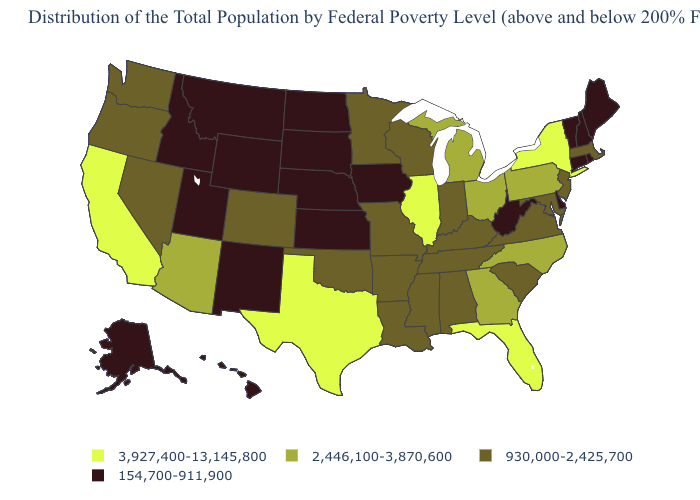What is the value of Kansas?
Write a very short answer. 154,700-911,900. Name the states that have a value in the range 930,000-2,425,700?
Concise answer only. Alabama, Arkansas, Colorado, Indiana, Kentucky, Louisiana, Maryland, Massachusetts, Minnesota, Mississippi, Missouri, Nevada, New Jersey, Oklahoma, Oregon, South Carolina, Tennessee, Virginia, Washington, Wisconsin. What is the highest value in the USA?
Quick response, please. 3,927,400-13,145,800. Name the states that have a value in the range 154,700-911,900?
Answer briefly. Alaska, Connecticut, Delaware, Hawaii, Idaho, Iowa, Kansas, Maine, Montana, Nebraska, New Hampshire, New Mexico, North Dakota, Rhode Island, South Dakota, Utah, Vermont, West Virginia, Wyoming. How many symbols are there in the legend?
Short answer required. 4. What is the value of Idaho?
Be succinct. 154,700-911,900. Among the states that border Nebraska , which have the highest value?
Be succinct. Colorado, Missouri. Name the states that have a value in the range 3,927,400-13,145,800?
Write a very short answer. California, Florida, Illinois, New York, Texas. How many symbols are there in the legend?
Be succinct. 4. What is the highest value in states that border Utah?
Be succinct. 2,446,100-3,870,600. What is the value of Nevada?
Concise answer only. 930,000-2,425,700. What is the lowest value in the USA?
Be succinct. 154,700-911,900. Which states have the lowest value in the USA?
Write a very short answer. Alaska, Connecticut, Delaware, Hawaii, Idaho, Iowa, Kansas, Maine, Montana, Nebraska, New Hampshire, New Mexico, North Dakota, Rhode Island, South Dakota, Utah, Vermont, West Virginia, Wyoming. Name the states that have a value in the range 3,927,400-13,145,800?
Quick response, please. California, Florida, Illinois, New York, Texas. Name the states that have a value in the range 2,446,100-3,870,600?
Keep it brief. Arizona, Georgia, Michigan, North Carolina, Ohio, Pennsylvania. 